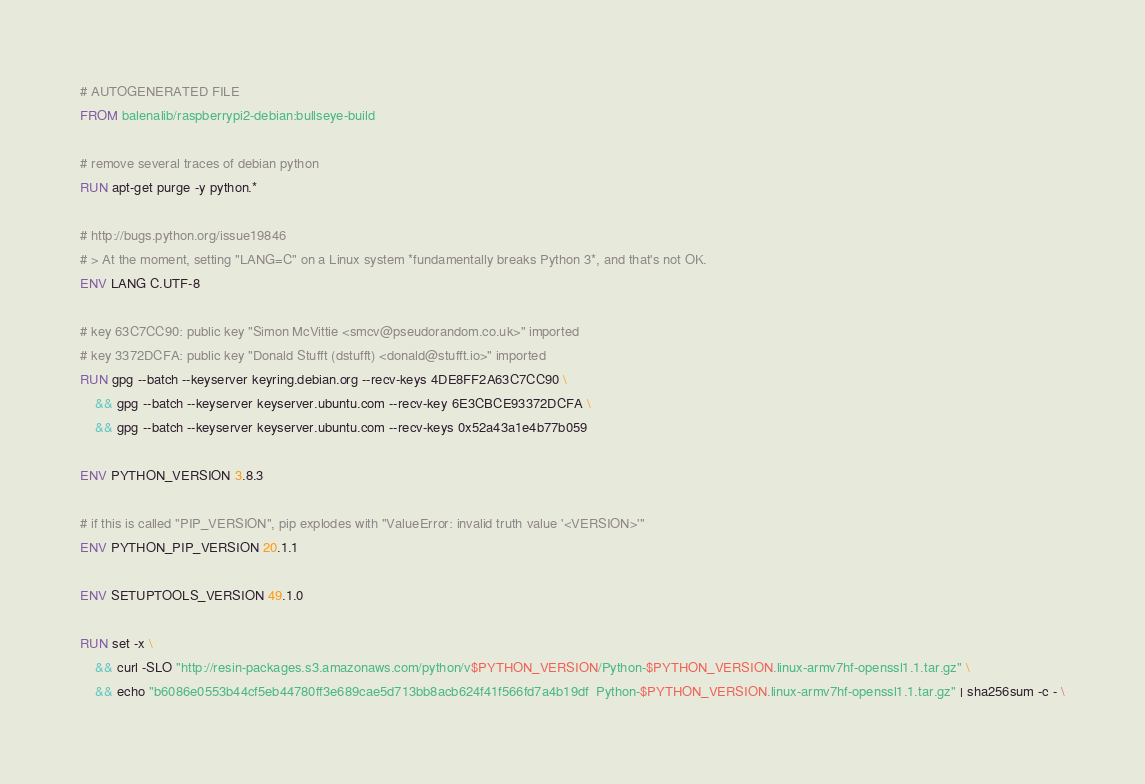<code> <loc_0><loc_0><loc_500><loc_500><_Dockerfile_># AUTOGENERATED FILE
FROM balenalib/raspberrypi2-debian:bullseye-build

# remove several traces of debian python
RUN apt-get purge -y python.*

# http://bugs.python.org/issue19846
# > At the moment, setting "LANG=C" on a Linux system *fundamentally breaks Python 3*, and that's not OK.
ENV LANG C.UTF-8

# key 63C7CC90: public key "Simon McVittie <smcv@pseudorandom.co.uk>" imported
# key 3372DCFA: public key "Donald Stufft (dstufft) <donald@stufft.io>" imported
RUN gpg --batch --keyserver keyring.debian.org --recv-keys 4DE8FF2A63C7CC90 \
	&& gpg --batch --keyserver keyserver.ubuntu.com --recv-key 6E3CBCE93372DCFA \
	&& gpg --batch --keyserver keyserver.ubuntu.com --recv-keys 0x52a43a1e4b77b059

ENV PYTHON_VERSION 3.8.3

# if this is called "PIP_VERSION", pip explodes with "ValueError: invalid truth value '<VERSION>'"
ENV PYTHON_PIP_VERSION 20.1.1

ENV SETUPTOOLS_VERSION 49.1.0

RUN set -x \
	&& curl -SLO "http://resin-packages.s3.amazonaws.com/python/v$PYTHON_VERSION/Python-$PYTHON_VERSION.linux-armv7hf-openssl1.1.tar.gz" \
	&& echo "b6086e0553b44cf5eb44780ff3e689cae5d713bb8acb624f41f566fd7a4b19df  Python-$PYTHON_VERSION.linux-armv7hf-openssl1.1.tar.gz" | sha256sum -c - \</code> 